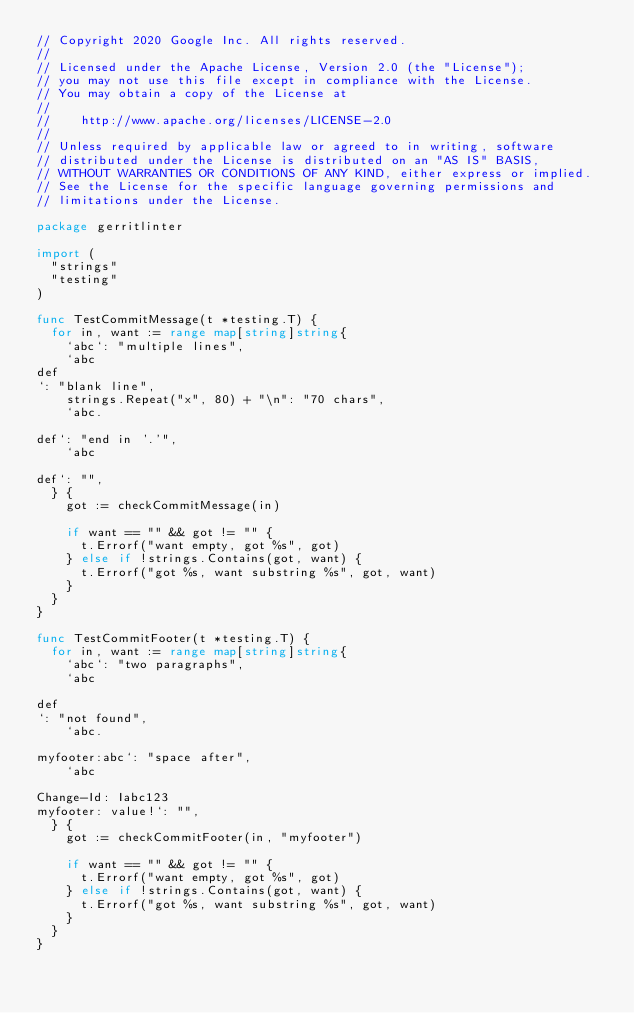Convert code to text. <code><loc_0><loc_0><loc_500><loc_500><_Go_>// Copyright 2020 Google Inc. All rights reserved.
//
// Licensed under the Apache License, Version 2.0 (the "License");
// you may not use this file except in compliance with the License.
// You may obtain a copy of the License at
//
//    http://www.apache.org/licenses/LICENSE-2.0
//
// Unless required by applicable law or agreed to in writing, software
// distributed under the License is distributed on an "AS IS" BASIS,
// WITHOUT WARRANTIES OR CONDITIONS OF ANY KIND, either express or implied.
// See the License for the specific language governing permissions and
// limitations under the License.

package gerritlinter

import (
	"strings"
	"testing"
)

func TestCommitMessage(t *testing.T) {
	for in, want := range map[string]string{
		`abc`: "multiple lines",
		`abc
def
`: "blank line",
		strings.Repeat("x", 80) + "\n": "70 chars",
		`abc.

def`: "end in '.'",
		`abc

def`: "",
	} {
		got := checkCommitMessage(in)

		if want == "" && got != "" {
			t.Errorf("want empty, got %s", got)
		} else if !strings.Contains(got, want) {
			t.Errorf("got %s, want substring %s", got, want)
		}
	}
}

func TestCommitFooter(t *testing.T) {
	for in, want := range map[string]string{
		`abc`: "two paragraphs",
		`abc

def
`: "not found",
		`abc.

myfooter:abc`: "space after",
		`abc

Change-Id: Iabc123
myfooter: value!`: "",
	} {
		got := checkCommitFooter(in, "myfooter")

		if want == "" && got != "" {
			t.Errorf("want empty, got %s", got)
		} else if !strings.Contains(got, want) {
			t.Errorf("got %s, want substring %s", got, want)
		}
	}
}
</code> 